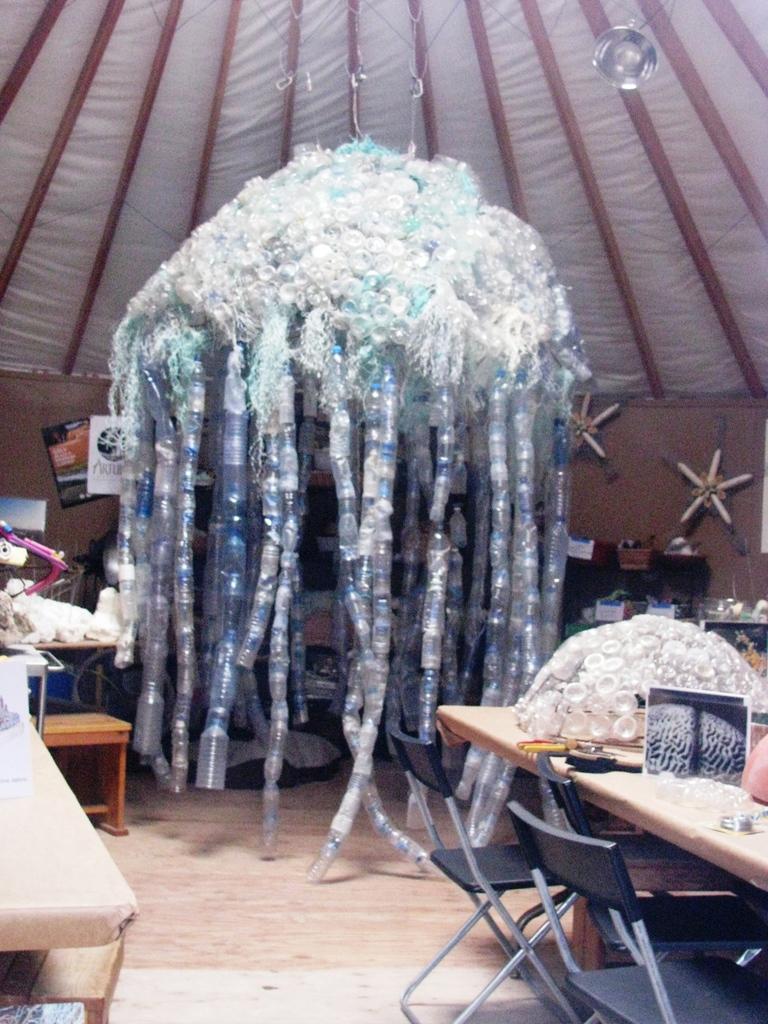In one or two sentences, can you explain what this image depicts? In this image I see art made of bottles over here and I see tables on which there are many things and I see chairs and I see the wall and I see the path. In the background I see the red and white color cloth. 